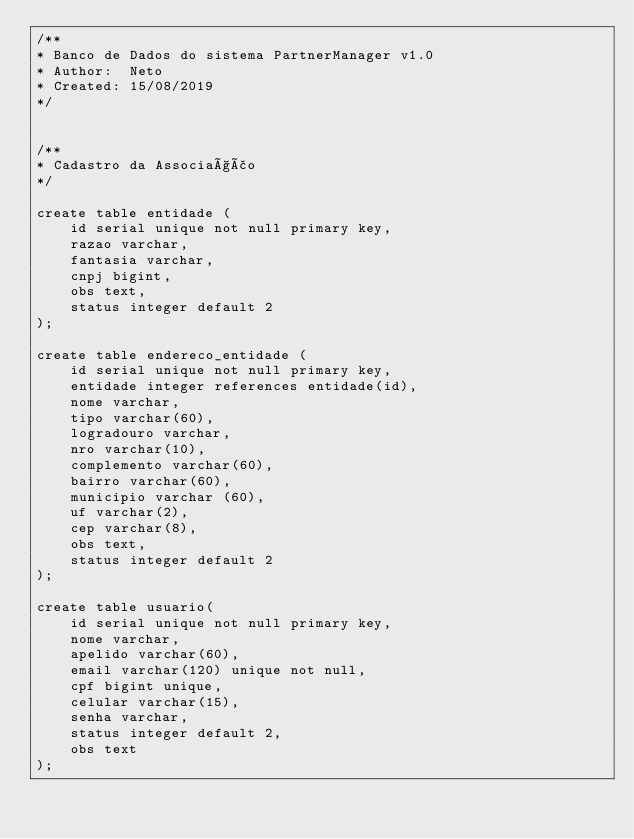<code> <loc_0><loc_0><loc_500><loc_500><_SQL_>/**
* Banco de Dados do sistema PartnerManager v1.0
* Author:  Neto
* Created: 15/08/2019
*/


/**
* Cadastro da Associação
*/

create table entidade (
    id serial unique not null primary key,
    razao varchar,
    fantasia varchar,
    cnpj bigint,
    obs text,
    status integer default 2
);

create table endereco_entidade (
    id serial unique not null primary key,
    entidade integer references entidade(id),
    nome varchar,
    tipo varchar(60),
    logradouro varchar, 
    nro varchar(10),
    complemento varchar(60),
    bairro varchar(60),
    municipio varchar (60),
    uf varchar(2),
    cep varchar(8),
    obs text,
    status integer default 2
);

create table usuario(
    id serial unique not null primary key,
    nome varchar, 
    apelido varchar(60),
    email varchar(120) unique not null,
    cpf bigint unique,
    celular varchar(15),
    senha varchar,
    status integer default 2,
    obs text
);
</code> 